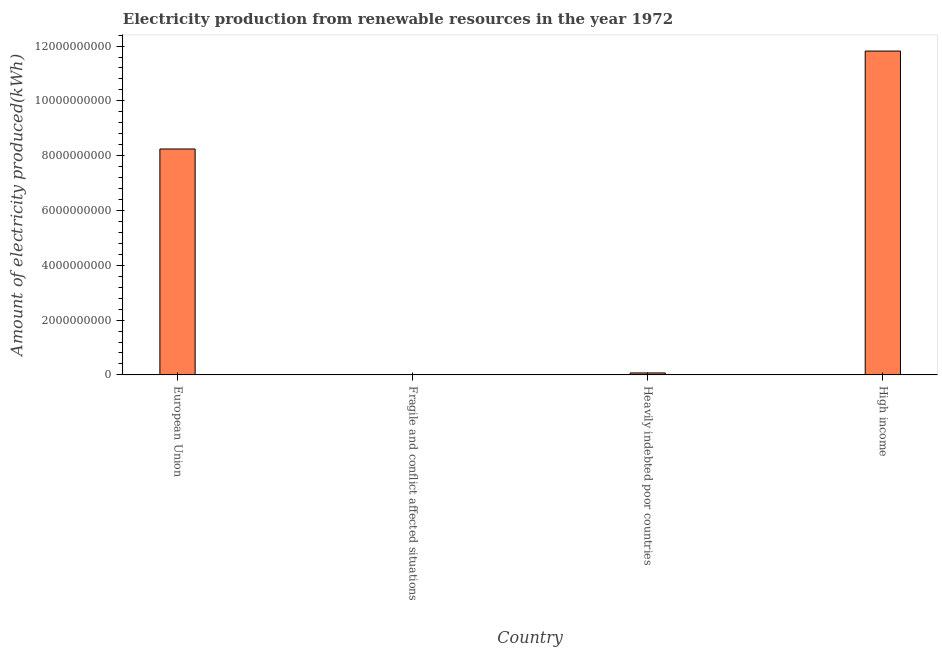Does the graph contain any zero values?
Give a very brief answer. No. What is the title of the graph?
Your response must be concise. Electricity production from renewable resources in the year 1972. What is the label or title of the Y-axis?
Offer a very short reply. Amount of electricity produced(kWh). What is the amount of electricity produced in High income?
Your answer should be very brief. 1.18e+1. Across all countries, what is the maximum amount of electricity produced?
Keep it short and to the point. 1.18e+1. Across all countries, what is the minimum amount of electricity produced?
Provide a short and direct response. 1.20e+07. In which country was the amount of electricity produced maximum?
Offer a terse response. High income. In which country was the amount of electricity produced minimum?
Your answer should be very brief. Fragile and conflict affected situations. What is the sum of the amount of electricity produced?
Offer a terse response. 2.01e+1. What is the difference between the amount of electricity produced in European Union and Heavily indebted poor countries?
Offer a terse response. 8.17e+09. What is the average amount of electricity produced per country?
Provide a short and direct response. 5.04e+09. What is the median amount of electricity produced?
Make the answer very short. 4.16e+09. In how many countries, is the amount of electricity produced greater than 11600000000 kWh?
Provide a succinct answer. 1. What is the ratio of the amount of electricity produced in Fragile and conflict affected situations to that in High income?
Offer a terse response. 0. What is the difference between the highest and the second highest amount of electricity produced?
Offer a terse response. 3.57e+09. What is the difference between the highest and the lowest amount of electricity produced?
Give a very brief answer. 1.18e+1. In how many countries, is the amount of electricity produced greater than the average amount of electricity produced taken over all countries?
Provide a succinct answer. 2. Are all the bars in the graph horizontal?
Provide a short and direct response. No. What is the difference between two consecutive major ticks on the Y-axis?
Your answer should be compact. 2.00e+09. Are the values on the major ticks of Y-axis written in scientific E-notation?
Provide a short and direct response. No. What is the Amount of electricity produced(kWh) of European Union?
Provide a succinct answer. 8.24e+09. What is the Amount of electricity produced(kWh) of Fragile and conflict affected situations?
Your answer should be very brief. 1.20e+07. What is the Amount of electricity produced(kWh) in Heavily indebted poor countries?
Provide a short and direct response. 7.20e+07. What is the Amount of electricity produced(kWh) in High income?
Give a very brief answer. 1.18e+1. What is the difference between the Amount of electricity produced(kWh) in European Union and Fragile and conflict affected situations?
Offer a very short reply. 8.23e+09. What is the difference between the Amount of electricity produced(kWh) in European Union and Heavily indebted poor countries?
Provide a short and direct response. 8.17e+09. What is the difference between the Amount of electricity produced(kWh) in European Union and High income?
Give a very brief answer. -3.57e+09. What is the difference between the Amount of electricity produced(kWh) in Fragile and conflict affected situations and Heavily indebted poor countries?
Provide a short and direct response. -6.00e+07. What is the difference between the Amount of electricity produced(kWh) in Fragile and conflict affected situations and High income?
Ensure brevity in your answer.  -1.18e+1. What is the difference between the Amount of electricity produced(kWh) in Heavily indebted poor countries and High income?
Provide a short and direct response. -1.17e+1. What is the ratio of the Amount of electricity produced(kWh) in European Union to that in Fragile and conflict affected situations?
Keep it short and to the point. 687. What is the ratio of the Amount of electricity produced(kWh) in European Union to that in Heavily indebted poor countries?
Offer a terse response. 114.5. What is the ratio of the Amount of electricity produced(kWh) in European Union to that in High income?
Your answer should be compact. 0.7. What is the ratio of the Amount of electricity produced(kWh) in Fragile and conflict affected situations to that in Heavily indebted poor countries?
Your answer should be very brief. 0.17. What is the ratio of the Amount of electricity produced(kWh) in Fragile and conflict affected situations to that in High income?
Provide a succinct answer. 0. What is the ratio of the Amount of electricity produced(kWh) in Heavily indebted poor countries to that in High income?
Offer a very short reply. 0.01. 